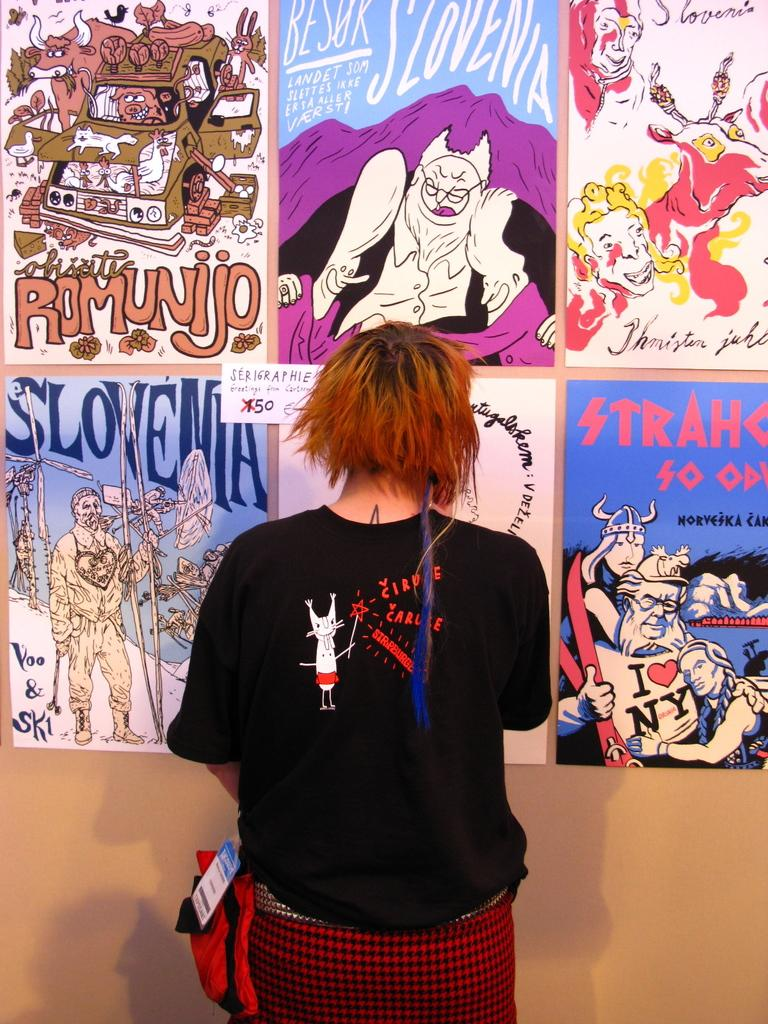<image>
Offer a succinct explanation of the picture presented. Woman standing in front of a wall with different posters including one that says slovenia. 